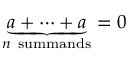Convert formula to latex. <formula><loc_0><loc_0><loc_500><loc_500>\underbrace { a + \cdots + a } _ { n { s u m m a n d s } } = 0</formula> 